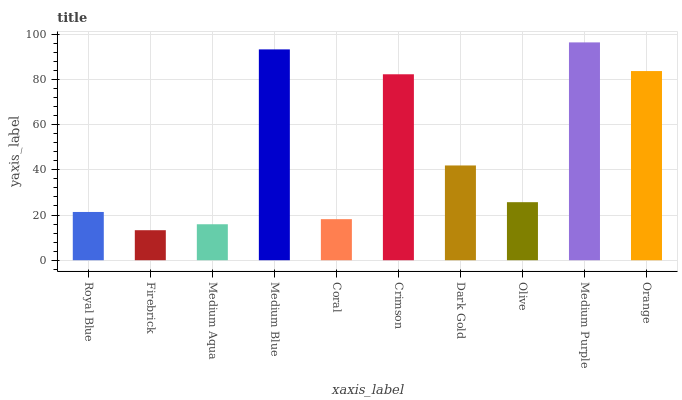Is Firebrick the minimum?
Answer yes or no. Yes. Is Medium Purple the maximum?
Answer yes or no. Yes. Is Medium Aqua the minimum?
Answer yes or no. No. Is Medium Aqua the maximum?
Answer yes or no. No. Is Medium Aqua greater than Firebrick?
Answer yes or no. Yes. Is Firebrick less than Medium Aqua?
Answer yes or no. Yes. Is Firebrick greater than Medium Aqua?
Answer yes or no. No. Is Medium Aqua less than Firebrick?
Answer yes or no. No. Is Dark Gold the high median?
Answer yes or no. Yes. Is Olive the low median?
Answer yes or no. Yes. Is Orange the high median?
Answer yes or no. No. Is Royal Blue the low median?
Answer yes or no. No. 